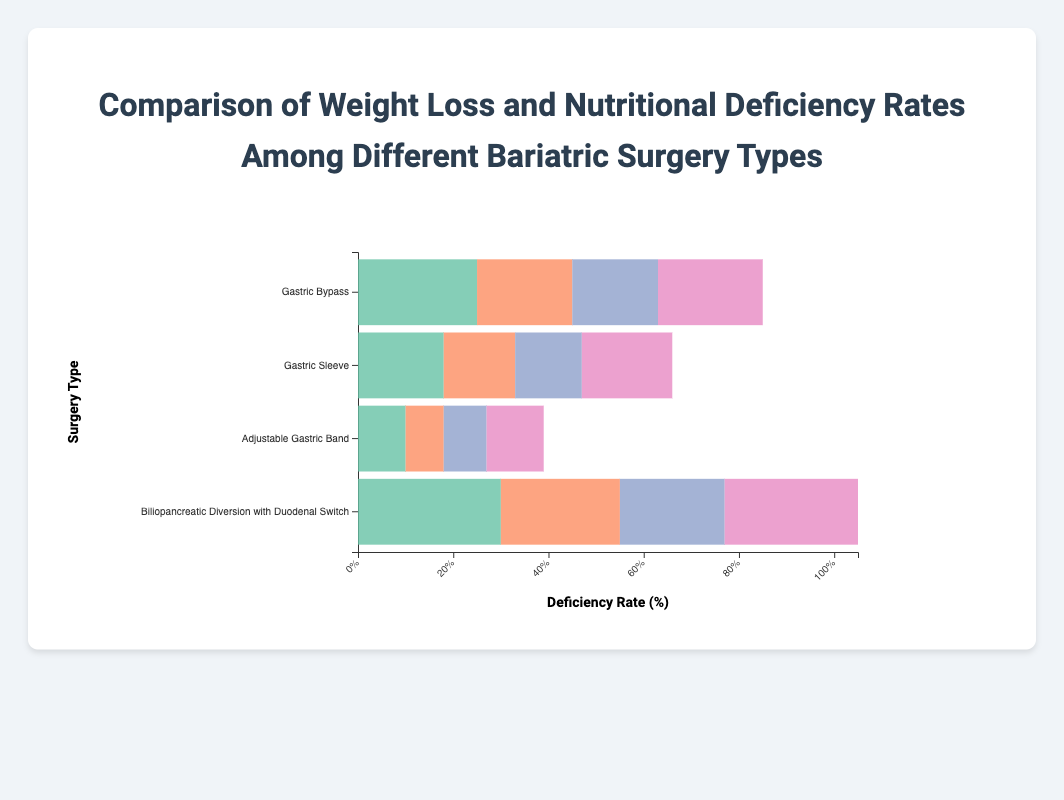What is the rate of Vitamin B12 deficiency in patients who underwent Gastric Bypass surgery? Look at the "Gastric Bypass" bar and identify the section corresponding to Vitamin B12 deficiency, which has a rate of 25%.
Answer: 25% Among the different bariatric surgeries, which type shows the highest overall deficiency rate? Sum up the deficiency rates for each surgery type and compare. Biliopancreatic Diversion with Duodenal Switch (30%+25%+22%+28%=105%) has the highest overall deficiency rate.
Answer: Biliopancreatic Diversion with Duodenal Switch Which surgery type has the lowest weight loss percentage? Identify the weight loss percentage labels next to each surgery. Adjustable Gastric Band has the lowest at 20%.
Answer: Adjustable Gastric Band Compare the weight loss percentages between Gastric Sleeve and Adjustable Gastric Band surgeries. Which is higher and by how much? Gastric Sleeve has 28% weight loss, and Adjustable Gastric Band has 20%. The difference is 28% - 20% = 8%.
Answer: Gastric Sleeve by 8% What is the total deficiency rate for Vitamin D across all surgery types combined? Add up the Vitamin D deficiency rates from all surgeries: 22%+19%+12%+28% = 81%.
Answer: 81% How does the Iron deficiency rate for Gastric Bypass compare to that of Gastric Sleeve? The Iron deficiency rate for Gastric Bypass is 20%, whereas for Gastric Sleeve it is 15%. 20% - 15% = 5% higher for Gastric Bypass.
Answer: 5% higher for Gastric Bypass Which type of surgery has the highest deficiency rate for Calcium? Identify the Calcium deficiency rates: Gastric Bypass (18%), Gastric Sleeve (14%), Adjustable Gastric Band (9%), Biliopancreatic Diversion with Duodenal Switch (22%). The highest is Biliopancreatic Diversion with Duodenal Switch at 22%.
Answer: Biliopancreatic Diversion with Duodenal Switch If you combine the deficiency rates of Vitamin B12 and Iron for all surgery types, which surgery type has the highest combined deficiency rate for these two vitamins? Combine Vitamin B12 and Iron deficiency rates for each type:
- Gastric Bypass: 25% + 20% = 45%
- Gastric Sleeve: 18% + 15% = 33%
- Adjustable Gastric Band: 10% + 8% = 18%
- Biliopancreatic Diversion with Duodenal Switch: 30% + 25% = 55%.
The highest combined rate is Biliopancreatic Diversion with Duodenal Switch.
Answer: Biliopancreatic Diversion with Duodenal Switch 